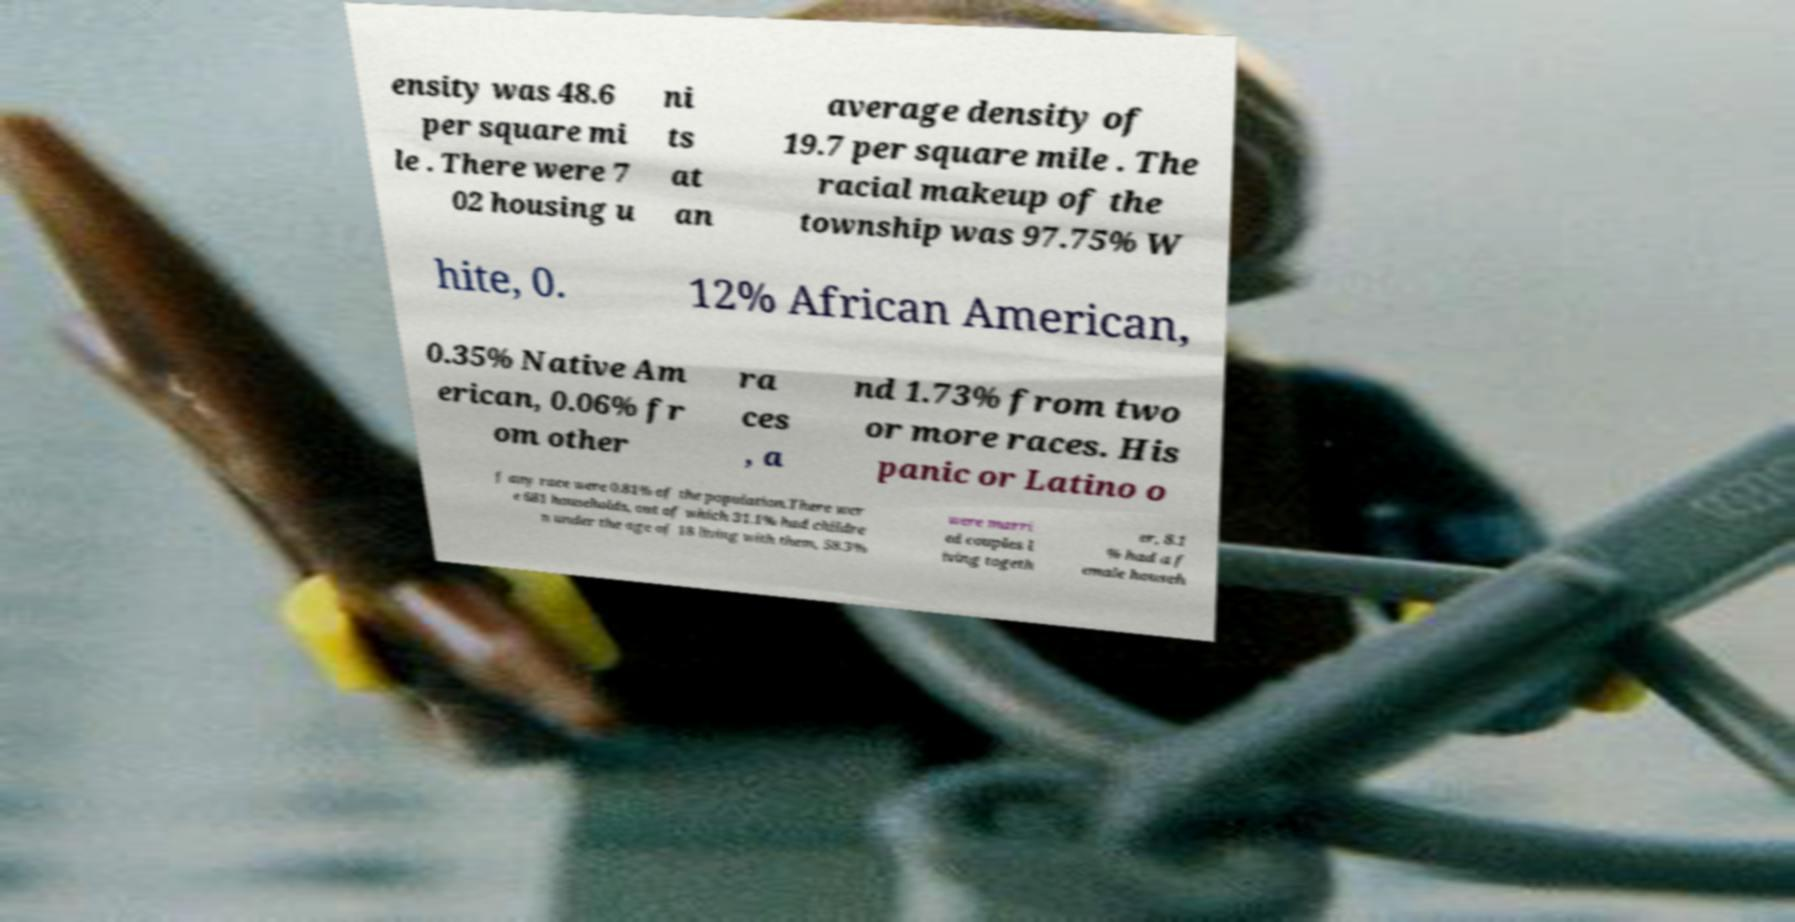There's text embedded in this image that I need extracted. Can you transcribe it verbatim? ensity was 48.6 per square mi le . There were 7 02 housing u ni ts at an average density of 19.7 per square mile . The racial makeup of the township was 97.75% W hite, 0. 12% African American, 0.35% Native Am erican, 0.06% fr om other ra ces , a nd 1.73% from two or more races. His panic or Latino o f any race were 0.81% of the population.There wer e 681 households, out of which 31.1% had childre n under the age of 18 living with them, 58.3% were marri ed couples l iving togeth er, 8.1 % had a f emale househ 